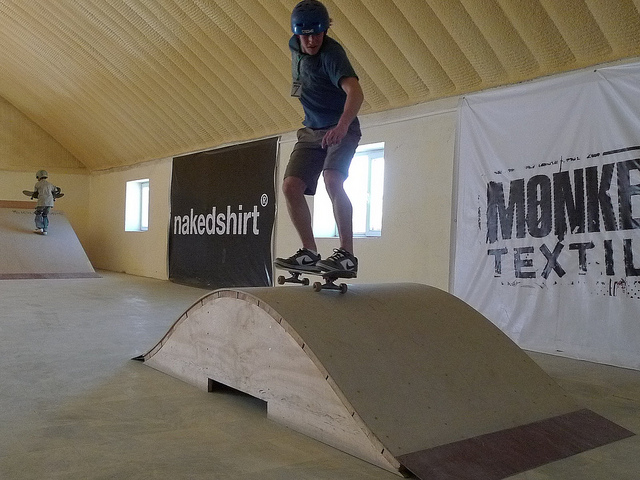Please transcribe the text information in this image. nakedshirt TEXTIL MONKE 